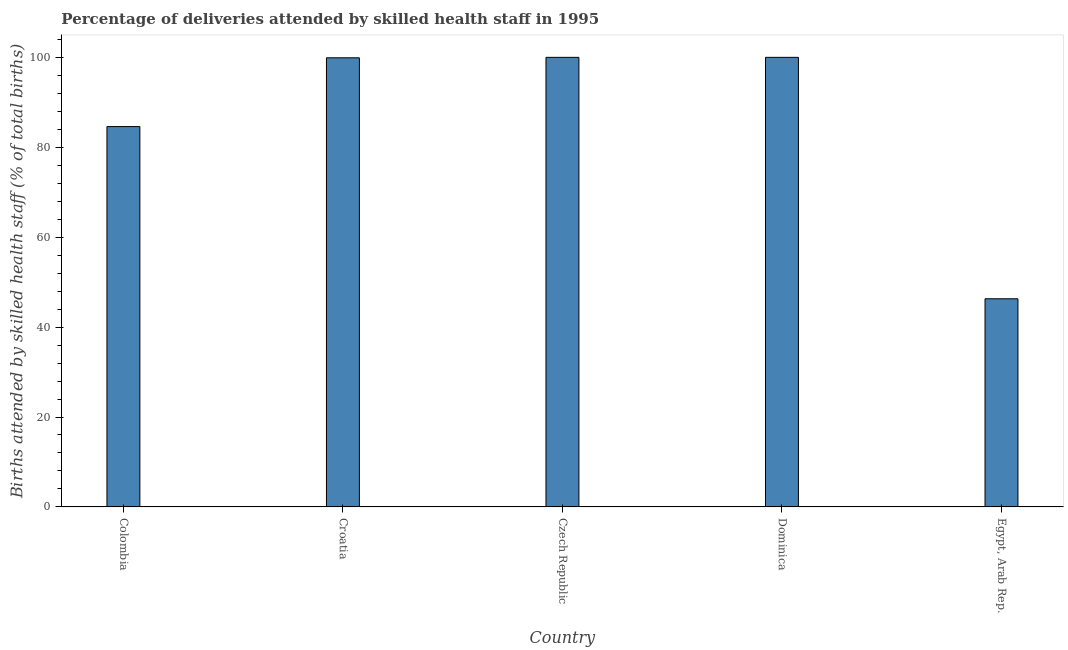What is the title of the graph?
Make the answer very short. Percentage of deliveries attended by skilled health staff in 1995. What is the label or title of the X-axis?
Ensure brevity in your answer.  Country. What is the label or title of the Y-axis?
Your response must be concise. Births attended by skilled health staff (% of total births). Across all countries, what is the minimum number of births attended by skilled health staff?
Make the answer very short. 46.3. In which country was the number of births attended by skilled health staff maximum?
Ensure brevity in your answer.  Czech Republic. In which country was the number of births attended by skilled health staff minimum?
Your answer should be very brief. Egypt, Arab Rep. What is the sum of the number of births attended by skilled health staff?
Provide a succinct answer. 430.8. What is the difference between the number of births attended by skilled health staff in Croatia and Egypt, Arab Rep.?
Your response must be concise. 53.6. What is the average number of births attended by skilled health staff per country?
Provide a succinct answer. 86.16. What is the median number of births attended by skilled health staff?
Your response must be concise. 99.9. What is the ratio of the number of births attended by skilled health staff in Czech Republic to that in Egypt, Arab Rep.?
Offer a terse response. 2.16. Is the number of births attended by skilled health staff in Czech Republic less than that in Dominica?
Your answer should be very brief. No. What is the difference between the highest and the second highest number of births attended by skilled health staff?
Offer a terse response. 0. Is the sum of the number of births attended by skilled health staff in Colombia and Dominica greater than the maximum number of births attended by skilled health staff across all countries?
Provide a short and direct response. Yes. What is the difference between the highest and the lowest number of births attended by skilled health staff?
Offer a very short reply. 53.7. In how many countries, is the number of births attended by skilled health staff greater than the average number of births attended by skilled health staff taken over all countries?
Your answer should be compact. 3. Are all the bars in the graph horizontal?
Your response must be concise. No. What is the difference between two consecutive major ticks on the Y-axis?
Your response must be concise. 20. Are the values on the major ticks of Y-axis written in scientific E-notation?
Ensure brevity in your answer.  No. What is the Births attended by skilled health staff (% of total births) of Colombia?
Your answer should be very brief. 84.6. What is the Births attended by skilled health staff (% of total births) in Croatia?
Make the answer very short. 99.9. What is the Births attended by skilled health staff (% of total births) in Egypt, Arab Rep.?
Your response must be concise. 46.3. What is the difference between the Births attended by skilled health staff (% of total births) in Colombia and Croatia?
Ensure brevity in your answer.  -15.3. What is the difference between the Births attended by skilled health staff (% of total births) in Colombia and Czech Republic?
Offer a very short reply. -15.4. What is the difference between the Births attended by skilled health staff (% of total births) in Colombia and Dominica?
Give a very brief answer. -15.4. What is the difference between the Births attended by skilled health staff (% of total births) in Colombia and Egypt, Arab Rep.?
Give a very brief answer. 38.3. What is the difference between the Births attended by skilled health staff (% of total births) in Croatia and Dominica?
Offer a terse response. -0.1. What is the difference between the Births attended by skilled health staff (% of total births) in Croatia and Egypt, Arab Rep.?
Offer a terse response. 53.6. What is the difference between the Births attended by skilled health staff (% of total births) in Czech Republic and Dominica?
Provide a short and direct response. 0. What is the difference between the Births attended by skilled health staff (% of total births) in Czech Republic and Egypt, Arab Rep.?
Give a very brief answer. 53.7. What is the difference between the Births attended by skilled health staff (% of total births) in Dominica and Egypt, Arab Rep.?
Provide a short and direct response. 53.7. What is the ratio of the Births attended by skilled health staff (% of total births) in Colombia to that in Croatia?
Keep it short and to the point. 0.85. What is the ratio of the Births attended by skilled health staff (% of total births) in Colombia to that in Czech Republic?
Offer a very short reply. 0.85. What is the ratio of the Births attended by skilled health staff (% of total births) in Colombia to that in Dominica?
Offer a terse response. 0.85. What is the ratio of the Births attended by skilled health staff (% of total births) in Colombia to that in Egypt, Arab Rep.?
Your answer should be very brief. 1.83. What is the ratio of the Births attended by skilled health staff (% of total births) in Croatia to that in Czech Republic?
Your response must be concise. 1. What is the ratio of the Births attended by skilled health staff (% of total births) in Croatia to that in Egypt, Arab Rep.?
Make the answer very short. 2.16. What is the ratio of the Births attended by skilled health staff (% of total births) in Czech Republic to that in Egypt, Arab Rep.?
Provide a succinct answer. 2.16. What is the ratio of the Births attended by skilled health staff (% of total births) in Dominica to that in Egypt, Arab Rep.?
Provide a succinct answer. 2.16. 